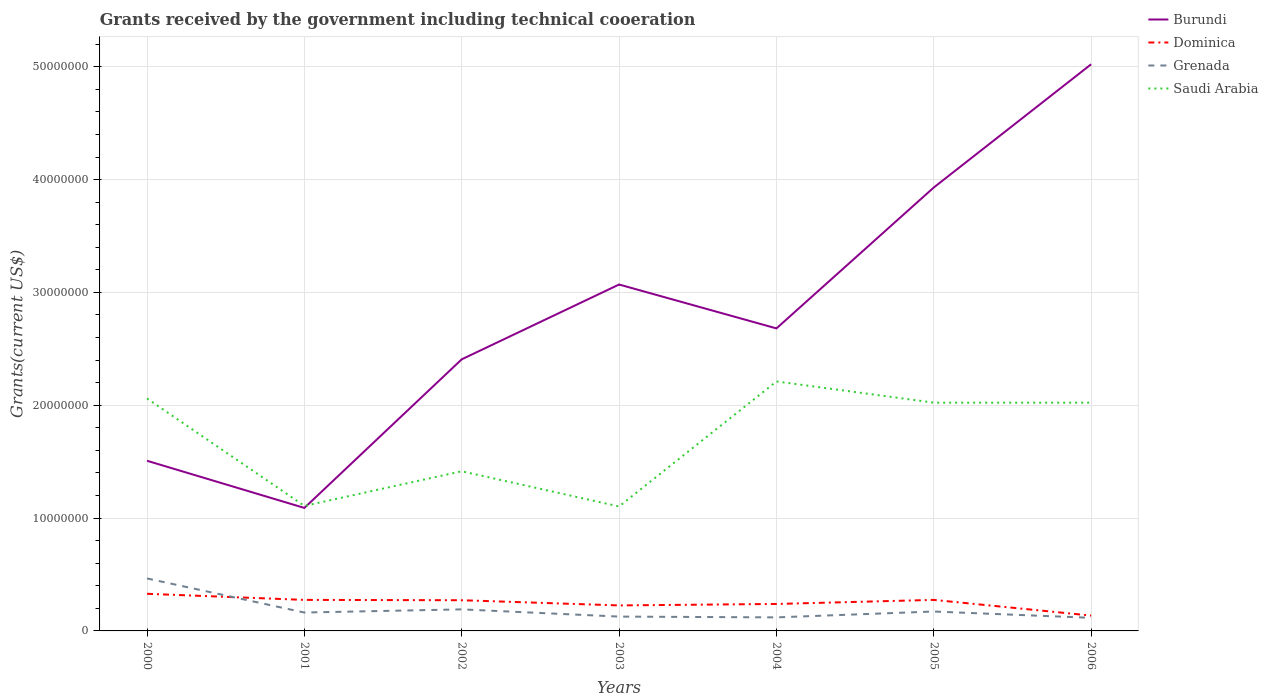Is the number of lines equal to the number of legend labels?
Make the answer very short. Yes. Across all years, what is the maximum total grants received by the government in Saudi Arabia?
Offer a very short reply. 1.10e+07. In which year was the total grants received by the government in Grenada maximum?
Offer a very short reply. 2006. What is the total total grants received by the government in Dominica in the graph?
Provide a succinct answer. 1.03e+06. What is the difference between the highest and the second highest total grants received by the government in Saudi Arabia?
Give a very brief answer. 1.11e+07. What is the difference between the highest and the lowest total grants received by the government in Dominica?
Your response must be concise. 4. Is the total grants received by the government in Saudi Arabia strictly greater than the total grants received by the government in Grenada over the years?
Provide a short and direct response. No. How many lines are there?
Make the answer very short. 4. What is the difference between two consecutive major ticks on the Y-axis?
Provide a succinct answer. 1.00e+07. Where does the legend appear in the graph?
Provide a succinct answer. Top right. How many legend labels are there?
Ensure brevity in your answer.  4. What is the title of the graph?
Keep it short and to the point. Grants received by the government including technical cooeration. Does "Burkina Faso" appear as one of the legend labels in the graph?
Make the answer very short. No. What is the label or title of the X-axis?
Ensure brevity in your answer.  Years. What is the label or title of the Y-axis?
Your answer should be very brief. Grants(current US$). What is the Grants(current US$) of Burundi in 2000?
Ensure brevity in your answer.  1.51e+07. What is the Grants(current US$) of Dominica in 2000?
Make the answer very short. 3.29e+06. What is the Grants(current US$) in Grenada in 2000?
Your response must be concise. 4.65e+06. What is the Grants(current US$) of Saudi Arabia in 2000?
Ensure brevity in your answer.  2.06e+07. What is the Grants(current US$) in Burundi in 2001?
Offer a very short reply. 1.09e+07. What is the Grants(current US$) of Dominica in 2001?
Ensure brevity in your answer.  2.75e+06. What is the Grants(current US$) of Grenada in 2001?
Your answer should be very brief. 1.63e+06. What is the Grants(current US$) of Saudi Arabia in 2001?
Your answer should be very brief. 1.11e+07. What is the Grants(current US$) of Burundi in 2002?
Offer a very short reply. 2.41e+07. What is the Grants(current US$) in Dominica in 2002?
Keep it short and to the point. 2.72e+06. What is the Grants(current US$) of Grenada in 2002?
Offer a terse response. 1.91e+06. What is the Grants(current US$) of Saudi Arabia in 2002?
Provide a succinct answer. 1.42e+07. What is the Grants(current US$) in Burundi in 2003?
Your answer should be compact. 3.07e+07. What is the Grants(current US$) in Dominica in 2003?
Offer a very short reply. 2.26e+06. What is the Grants(current US$) in Grenada in 2003?
Give a very brief answer. 1.27e+06. What is the Grants(current US$) of Saudi Arabia in 2003?
Keep it short and to the point. 1.10e+07. What is the Grants(current US$) in Burundi in 2004?
Your answer should be compact. 2.68e+07. What is the Grants(current US$) of Dominica in 2004?
Offer a terse response. 2.39e+06. What is the Grants(current US$) of Grenada in 2004?
Your response must be concise. 1.20e+06. What is the Grants(current US$) in Saudi Arabia in 2004?
Give a very brief answer. 2.21e+07. What is the Grants(current US$) of Burundi in 2005?
Keep it short and to the point. 3.93e+07. What is the Grants(current US$) of Dominica in 2005?
Provide a short and direct response. 2.75e+06. What is the Grants(current US$) in Grenada in 2005?
Your answer should be compact. 1.72e+06. What is the Grants(current US$) of Saudi Arabia in 2005?
Your answer should be compact. 2.02e+07. What is the Grants(current US$) of Burundi in 2006?
Provide a short and direct response. 5.02e+07. What is the Grants(current US$) of Dominica in 2006?
Offer a terse response. 1.36e+06. What is the Grants(current US$) in Grenada in 2006?
Offer a very short reply. 1.16e+06. What is the Grants(current US$) of Saudi Arabia in 2006?
Offer a terse response. 2.02e+07. Across all years, what is the maximum Grants(current US$) of Burundi?
Offer a terse response. 5.02e+07. Across all years, what is the maximum Grants(current US$) of Dominica?
Your answer should be compact. 3.29e+06. Across all years, what is the maximum Grants(current US$) of Grenada?
Keep it short and to the point. 4.65e+06. Across all years, what is the maximum Grants(current US$) of Saudi Arabia?
Provide a succinct answer. 2.21e+07. Across all years, what is the minimum Grants(current US$) of Burundi?
Make the answer very short. 1.09e+07. Across all years, what is the minimum Grants(current US$) of Dominica?
Offer a terse response. 1.36e+06. Across all years, what is the minimum Grants(current US$) of Grenada?
Offer a very short reply. 1.16e+06. Across all years, what is the minimum Grants(current US$) of Saudi Arabia?
Give a very brief answer. 1.10e+07. What is the total Grants(current US$) of Burundi in the graph?
Your response must be concise. 1.97e+08. What is the total Grants(current US$) of Dominica in the graph?
Offer a very short reply. 1.75e+07. What is the total Grants(current US$) of Grenada in the graph?
Your response must be concise. 1.35e+07. What is the total Grants(current US$) in Saudi Arabia in the graph?
Offer a terse response. 1.19e+08. What is the difference between the Grants(current US$) in Burundi in 2000 and that in 2001?
Provide a succinct answer. 4.18e+06. What is the difference between the Grants(current US$) of Dominica in 2000 and that in 2001?
Your answer should be very brief. 5.40e+05. What is the difference between the Grants(current US$) in Grenada in 2000 and that in 2001?
Offer a terse response. 3.02e+06. What is the difference between the Grants(current US$) of Saudi Arabia in 2000 and that in 2001?
Offer a terse response. 9.52e+06. What is the difference between the Grants(current US$) of Burundi in 2000 and that in 2002?
Keep it short and to the point. -8.99e+06. What is the difference between the Grants(current US$) of Dominica in 2000 and that in 2002?
Offer a terse response. 5.70e+05. What is the difference between the Grants(current US$) of Grenada in 2000 and that in 2002?
Your response must be concise. 2.74e+06. What is the difference between the Grants(current US$) in Saudi Arabia in 2000 and that in 2002?
Keep it short and to the point. 6.45e+06. What is the difference between the Grants(current US$) in Burundi in 2000 and that in 2003?
Ensure brevity in your answer.  -1.56e+07. What is the difference between the Grants(current US$) in Dominica in 2000 and that in 2003?
Offer a very short reply. 1.03e+06. What is the difference between the Grants(current US$) of Grenada in 2000 and that in 2003?
Your answer should be compact. 3.38e+06. What is the difference between the Grants(current US$) in Saudi Arabia in 2000 and that in 2003?
Your answer should be very brief. 9.57e+06. What is the difference between the Grants(current US$) of Burundi in 2000 and that in 2004?
Keep it short and to the point. -1.17e+07. What is the difference between the Grants(current US$) of Grenada in 2000 and that in 2004?
Make the answer very short. 3.45e+06. What is the difference between the Grants(current US$) of Saudi Arabia in 2000 and that in 2004?
Give a very brief answer. -1.51e+06. What is the difference between the Grants(current US$) in Burundi in 2000 and that in 2005?
Provide a succinct answer. -2.42e+07. What is the difference between the Grants(current US$) of Dominica in 2000 and that in 2005?
Provide a succinct answer. 5.40e+05. What is the difference between the Grants(current US$) in Grenada in 2000 and that in 2005?
Offer a terse response. 2.93e+06. What is the difference between the Grants(current US$) in Saudi Arabia in 2000 and that in 2005?
Your answer should be compact. 3.70e+05. What is the difference between the Grants(current US$) of Burundi in 2000 and that in 2006?
Your answer should be compact. -3.51e+07. What is the difference between the Grants(current US$) of Dominica in 2000 and that in 2006?
Offer a very short reply. 1.93e+06. What is the difference between the Grants(current US$) in Grenada in 2000 and that in 2006?
Offer a very short reply. 3.49e+06. What is the difference between the Grants(current US$) of Burundi in 2001 and that in 2002?
Your answer should be compact. -1.32e+07. What is the difference between the Grants(current US$) of Dominica in 2001 and that in 2002?
Provide a succinct answer. 3.00e+04. What is the difference between the Grants(current US$) in Grenada in 2001 and that in 2002?
Your answer should be very brief. -2.80e+05. What is the difference between the Grants(current US$) of Saudi Arabia in 2001 and that in 2002?
Offer a terse response. -3.07e+06. What is the difference between the Grants(current US$) of Burundi in 2001 and that in 2003?
Your response must be concise. -1.98e+07. What is the difference between the Grants(current US$) in Dominica in 2001 and that in 2003?
Ensure brevity in your answer.  4.90e+05. What is the difference between the Grants(current US$) in Grenada in 2001 and that in 2003?
Provide a succinct answer. 3.60e+05. What is the difference between the Grants(current US$) in Saudi Arabia in 2001 and that in 2003?
Keep it short and to the point. 5.00e+04. What is the difference between the Grants(current US$) of Burundi in 2001 and that in 2004?
Make the answer very short. -1.59e+07. What is the difference between the Grants(current US$) in Saudi Arabia in 2001 and that in 2004?
Offer a terse response. -1.10e+07. What is the difference between the Grants(current US$) of Burundi in 2001 and that in 2005?
Make the answer very short. -2.84e+07. What is the difference between the Grants(current US$) of Grenada in 2001 and that in 2005?
Your answer should be compact. -9.00e+04. What is the difference between the Grants(current US$) in Saudi Arabia in 2001 and that in 2005?
Your response must be concise. -9.15e+06. What is the difference between the Grants(current US$) of Burundi in 2001 and that in 2006?
Make the answer very short. -3.93e+07. What is the difference between the Grants(current US$) in Dominica in 2001 and that in 2006?
Your response must be concise. 1.39e+06. What is the difference between the Grants(current US$) in Grenada in 2001 and that in 2006?
Your answer should be compact. 4.70e+05. What is the difference between the Grants(current US$) of Saudi Arabia in 2001 and that in 2006?
Offer a terse response. -9.15e+06. What is the difference between the Grants(current US$) in Burundi in 2002 and that in 2003?
Your response must be concise. -6.63e+06. What is the difference between the Grants(current US$) of Grenada in 2002 and that in 2003?
Keep it short and to the point. 6.40e+05. What is the difference between the Grants(current US$) in Saudi Arabia in 2002 and that in 2003?
Ensure brevity in your answer.  3.12e+06. What is the difference between the Grants(current US$) in Burundi in 2002 and that in 2004?
Your response must be concise. -2.74e+06. What is the difference between the Grants(current US$) of Dominica in 2002 and that in 2004?
Your response must be concise. 3.30e+05. What is the difference between the Grants(current US$) in Grenada in 2002 and that in 2004?
Make the answer very short. 7.10e+05. What is the difference between the Grants(current US$) of Saudi Arabia in 2002 and that in 2004?
Keep it short and to the point. -7.96e+06. What is the difference between the Grants(current US$) of Burundi in 2002 and that in 2005?
Provide a short and direct response. -1.52e+07. What is the difference between the Grants(current US$) of Grenada in 2002 and that in 2005?
Keep it short and to the point. 1.90e+05. What is the difference between the Grants(current US$) in Saudi Arabia in 2002 and that in 2005?
Your response must be concise. -6.08e+06. What is the difference between the Grants(current US$) in Burundi in 2002 and that in 2006?
Offer a very short reply. -2.62e+07. What is the difference between the Grants(current US$) of Dominica in 2002 and that in 2006?
Your answer should be compact. 1.36e+06. What is the difference between the Grants(current US$) in Grenada in 2002 and that in 2006?
Offer a terse response. 7.50e+05. What is the difference between the Grants(current US$) in Saudi Arabia in 2002 and that in 2006?
Give a very brief answer. -6.08e+06. What is the difference between the Grants(current US$) in Burundi in 2003 and that in 2004?
Provide a short and direct response. 3.89e+06. What is the difference between the Grants(current US$) of Grenada in 2003 and that in 2004?
Your response must be concise. 7.00e+04. What is the difference between the Grants(current US$) in Saudi Arabia in 2003 and that in 2004?
Offer a very short reply. -1.11e+07. What is the difference between the Grants(current US$) in Burundi in 2003 and that in 2005?
Make the answer very short. -8.60e+06. What is the difference between the Grants(current US$) of Dominica in 2003 and that in 2005?
Your answer should be compact. -4.90e+05. What is the difference between the Grants(current US$) of Grenada in 2003 and that in 2005?
Give a very brief answer. -4.50e+05. What is the difference between the Grants(current US$) of Saudi Arabia in 2003 and that in 2005?
Keep it short and to the point. -9.20e+06. What is the difference between the Grants(current US$) in Burundi in 2003 and that in 2006?
Offer a very short reply. -1.95e+07. What is the difference between the Grants(current US$) of Grenada in 2003 and that in 2006?
Ensure brevity in your answer.  1.10e+05. What is the difference between the Grants(current US$) in Saudi Arabia in 2003 and that in 2006?
Offer a terse response. -9.20e+06. What is the difference between the Grants(current US$) of Burundi in 2004 and that in 2005?
Your answer should be compact. -1.25e+07. What is the difference between the Grants(current US$) in Dominica in 2004 and that in 2005?
Offer a terse response. -3.60e+05. What is the difference between the Grants(current US$) in Grenada in 2004 and that in 2005?
Give a very brief answer. -5.20e+05. What is the difference between the Grants(current US$) in Saudi Arabia in 2004 and that in 2005?
Provide a succinct answer. 1.88e+06. What is the difference between the Grants(current US$) in Burundi in 2004 and that in 2006?
Your answer should be compact. -2.34e+07. What is the difference between the Grants(current US$) of Dominica in 2004 and that in 2006?
Give a very brief answer. 1.03e+06. What is the difference between the Grants(current US$) in Saudi Arabia in 2004 and that in 2006?
Your answer should be compact. 1.88e+06. What is the difference between the Grants(current US$) in Burundi in 2005 and that in 2006?
Provide a succinct answer. -1.09e+07. What is the difference between the Grants(current US$) in Dominica in 2005 and that in 2006?
Offer a very short reply. 1.39e+06. What is the difference between the Grants(current US$) in Grenada in 2005 and that in 2006?
Offer a terse response. 5.60e+05. What is the difference between the Grants(current US$) of Burundi in 2000 and the Grants(current US$) of Dominica in 2001?
Provide a succinct answer. 1.23e+07. What is the difference between the Grants(current US$) in Burundi in 2000 and the Grants(current US$) in Grenada in 2001?
Give a very brief answer. 1.34e+07. What is the difference between the Grants(current US$) of Dominica in 2000 and the Grants(current US$) of Grenada in 2001?
Make the answer very short. 1.66e+06. What is the difference between the Grants(current US$) in Dominica in 2000 and the Grants(current US$) in Saudi Arabia in 2001?
Your answer should be very brief. -7.79e+06. What is the difference between the Grants(current US$) in Grenada in 2000 and the Grants(current US$) in Saudi Arabia in 2001?
Your answer should be very brief. -6.43e+06. What is the difference between the Grants(current US$) of Burundi in 2000 and the Grants(current US$) of Dominica in 2002?
Your answer should be very brief. 1.24e+07. What is the difference between the Grants(current US$) in Burundi in 2000 and the Grants(current US$) in Grenada in 2002?
Ensure brevity in your answer.  1.32e+07. What is the difference between the Grants(current US$) in Burundi in 2000 and the Grants(current US$) in Saudi Arabia in 2002?
Offer a very short reply. 9.30e+05. What is the difference between the Grants(current US$) in Dominica in 2000 and the Grants(current US$) in Grenada in 2002?
Provide a succinct answer. 1.38e+06. What is the difference between the Grants(current US$) in Dominica in 2000 and the Grants(current US$) in Saudi Arabia in 2002?
Give a very brief answer. -1.09e+07. What is the difference between the Grants(current US$) in Grenada in 2000 and the Grants(current US$) in Saudi Arabia in 2002?
Make the answer very short. -9.50e+06. What is the difference between the Grants(current US$) of Burundi in 2000 and the Grants(current US$) of Dominica in 2003?
Provide a short and direct response. 1.28e+07. What is the difference between the Grants(current US$) in Burundi in 2000 and the Grants(current US$) in Grenada in 2003?
Your answer should be compact. 1.38e+07. What is the difference between the Grants(current US$) in Burundi in 2000 and the Grants(current US$) in Saudi Arabia in 2003?
Keep it short and to the point. 4.05e+06. What is the difference between the Grants(current US$) of Dominica in 2000 and the Grants(current US$) of Grenada in 2003?
Give a very brief answer. 2.02e+06. What is the difference between the Grants(current US$) in Dominica in 2000 and the Grants(current US$) in Saudi Arabia in 2003?
Provide a succinct answer. -7.74e+06. What is the difference between the Grants(current US$) in Grenada in 2000 and the Grants(current US$) in Saudi Arabia in 2003?
Ensure brevity in your answer.  -6.38e+06. What is the difference between the Grants(current US$) of Burundi in 2000 and the Grants(current US$) of Dominica in 2004?
Your answer should be compact. 1.27e+07. What is the difference between the Grants(current US$) in Burundi in 2000 and the Grants(current US$) in Grenada in 2004?
Ensure brevity in your answer.  1.39e+07. What is the difference between the Grants(current US$) in Burundi in 2000 and the Grants(current US$) in Saudi Arabia in 2004?
Make the answer very short. -7.03e+06. What is the difference between the Grants(current US$) of Dominica in 2000 and the Grants(current US$) of Grenada in 2004?
Provide a succinct answer. 2.09e+06. What is the difference between the Grants(current US$) of Dominica in 2000 and the Grants(current US$) of Saudi Arabia in 2004?
Keep it short and to the point. -1.88e+07. What is the difference between the Grants(current US$) in Grenada in 2000 and the Grants(current US$) in Saudi Arabia in 2004?
Make the answer very short. -1.75e+07. What is the difference between the Grants(current US$) in Burundi in 2000 and the Grants(current US$) in Dominica in 2005?
Provide a succinct answer. 1.23e+07. What is the difference between the Grants(current US$) in Burundi in 2000 and the Grants(current US$) in Grenada in 2005?
Provide a short and direct response. 1.34e+07. What is the difference between the Grants(current US$) in Burundi in 2000 and the Grants(current US$) in Saudi Arabia in 2005?
Make the answer very short. -5.15e+06. What is the difference between the Grants(current US$) in Dominica in 2000 and the Grants(current US$) in Grenada in 2005?
Provide a short and direct response. 1.57e+06. What is the difference between the Grants(current US$) of Dominica in 2000 and the Grants(current US$) of Saudi Arabia in 2005?
Ensure brevity in your answer.  -1.69e+07. What is the difference between the Grants(current US$) of Grenada in 2000 and the Grants(current US$) of Saudi Arabia in 2005?
Offer a terse response. -1.56e+07. What is the difference between the Grants(current US$) in Burundi in 2000 and the Grants(current US$) in Dominica in 2006?
Your answer should be very brief. 1.37e+07. What is the difference between the Grants(current US$) of Burundi in 2000 and the Grants(current US$) of Grenada in 2006?
Provide a succinct answer. 1.39e+07. What is the difference between the Grants(current US$) of Burundi in 2000 and the Grants(current US$) of Saudi Arabia in 2006?
Offer a terse response. -5.15e+06. What is the difference between the Grants(current US$) in Dominica in 2000 and the Grants(current US$) in Grenada in 2006?
Keep it short and to the point. 2.13e+06. What is the difference between the Grants(current US$) in Dominica in 2000 and the Grants(current US$) in Saudi Arabia in 2006?
Offer a terse response. -1.69e+07. What is the difference between the Grants(current US$) of Grenada in 2000 and the Grants(current US$) of Saudi Arabia in 2006?
Ensure brevity in your answer.  -1.56e+07. What is the difference between the Grants(current US$) of Burundi in 2001 and the Grants(current US$) of Dominica in 2002?
Make the answer very short. 8.18e+06. What is the difference between the Grants(current US$) in Burundi in 2001 and the Grants(current US$) in Grenada in 2002?
Keep it short and to the point. 8.99e+06. What is the difference between the Grants(current US$) in Burundi in 2001 and the Grants(current US$) in Saudi Arabia in 2002?
Offer a terse response. -3.25e+06. What is the difference between the Grants(current US$) of Dominica in 2001 and the Grants(current US$) of Grenada in 2002?
Your response must be concise. 8.40e+05. What is the difference between the Grants(current US$) of Dominica in 2001 and the Grants(current US$) of Saudi Arabia in 2002?
Your answer should be compact. -1.14e+07. What is the difference between the Grants(current US$) of Grenada in 2001 and the Grants(current US$) of Saudi Arabia in 2002?
Your answer should be compact. -1.25e+07. What is the difference between the Grants(current US$) of Burundi in 2001 and the Grants(current US$) of Dominica in 2003?
Give a very brief answer. 8.64e+06. What is the difference between the Grants(current US$) of Burundi in 2001 and the Grants(current US$) of Grenada in 2003?
Your answer should be compact. 9.63e+06. What is the difference between the Grants(current US$) in Burundi in 2001 and the Grants(current US$) in Saudi Arabia in 2003?
Provide a short and direct response. -1.30e+05. What is the difference between the Grants(current US$) of Dominica in 2001 and the Grants(current US$) of Grenada in 2003?
Ensure brevity in your answer.  1.48e+06. What is the difference between the Grants(current US$) in Dominica in 2001 and the Grants(current US$) in Saudi Arabia in 2003?
Give a very brief answer. -8.28e+06. What is the difference between the Grants(current US$) of Grenada in 2001 and the Grants(current US$) of Saudi Arabia in 2003?
Make the answer very short. -9.40e+06. What is the difference between the Grants(current US$) of Burundi in 2001 and the Grants(current US$) of Dominica in 2004?
Your answer should be very brief. 8.51e+06. What is the difference between the Grants(current US$) of Burundi in 2001 and the Grants(current US$) of Grenada in 2004?
Ensure brevity in your answer.  9.70e+06. What is the difference between the Grants(current US$) in Burundi in 2001 and the Grants(current US$) in Saudi Arabia in 2004?
Keep it short and to the point. -1.12e+07. What is the difference between the Grants(current US$) in Dominica in 2001 and the Grants(current US$) in Grenada in 2004?
Offer a very short reply. 1.55e+06. What is the difference between the Grants(current US$) in Dominica in 2001 and the Grants(current US$) in Saudi Arabia in 2004?
Provide a short and direct response. -1.94e+07. What is the difference between the Grants(current US$) of Grenada in 2001 and the Grants(current US$) of Saudi Arabia in 2004?
Provide a short and direct response. -2.05e+07. What is the difference between the Grants(current US$) of Burundi in 2001 and the Grants(current US$) of Dominica in 2005?
Your answer should be very brief. 8.15e+06. What is the difference between the Grants(current US$) in Burundi in 2001 and the Grants(current US$) in Grenada in 2005?
Provide a short and direct response. 9.18e+06. What is the difference between the Grants(current US$) in Burundi in 2001 and the Grants(current US$) in Saudi Arabia in 2005?
Make the answer very short. -9.33e+06. What is the difference between the Grants(current US$) in Dominica in 2001 and the Grants(current US$) in Grenada in 2005?
Offer a very short reply. 1.03e+06. What is the difference between the Grants(current US$) of Dominica in 2001 and the Grants(current US$) of Saudi Arabia in 2005?
Your answer should be very brief. -1.75e+07. What is the difference between the Grants(current US$) in Grenada in 2001 and the Grants(current US$) in Saudi Arabia in 2005?
Provide a succinct answer. -1.86e+07. What is the difference between the Grants(current US$) of Burundi in 2001 and the Grants(current US$) of Dominica in 2006?
Offer a very short reply. 9.54e+06. What is the difference between the Grants(current US$) of Burundi in 2001 and the Grants(current US$) of Grenada in 2006?
Give a very brief answer. 9.74e+06. What is the difference between the Grants(current US$) in Burundi in 2001 and the Grants(current US$) in Saudi Arabia in 2006?
Provide a succinct answer. -9.33e+06. What is the difference between the Grants(current US$) of Dominica in 2001 and the Grants(current US$) of Grenada in 2006?
Your response must be concise. 1.59e+06. What is the difference between the Grants(current US$) of Dominica in 2001 and the Grants(current US$) of Saudi Arabia in 2006?
Your answer should be compact. -1.75e+07. What is the difference between the Grants(current US$) in Grenada in 2001 and the Grants(current US$) in Saudi Arabia in 2006?
Provide a short and direct response. -1.86e+07. What is the difference between the Grants(current US$) of Burundi in 2002 and the Grants(current US$) of Dominica in 2003?
Give a very brief answer. 2.18e+07. What is the difference between the Grants(current US$) in Burundi in 2002 and the Grants(current US$) in Grenada in 2003?
Your response must be concise. 2.28e+07. What is the difference between the Grants(current US$) of Burundi in 2002 and the Grants(current US$) of Saudi Arabia in 2003?
Provide a succinct answer. 1.30e+07. What is the difference between the Grants(current US$) in Dominica in 2002 and the Grants(current US$) in Grenada in 2003?
Give a very brief answer. 1.45e+06. What is the difference between the Grants(current US$) in Dominica in 2002 and the Grants(current US$) in Saudi Arabia in 2003?
Give a very brief answer. -8.31e+06. What is the difference between the Grants(current US$) of Grenada in 2002 and the Grants(current US$) of Saudi Arabia in 2003?
Offer a terse response. -9.12e+06. What is the difference between the Grants(current US$) in Burundi in 2002 and the Grants(current US$) in Dominica in 2004?
Provide a short and direct response. 2.17e+07. What is the difference between the Grants(current US$) in Burundi in 2002 and the Grants(current US$) in Grenada in 2004?
Make the answer very short. 2.29e+07. What is the difference between the Grants(current US$) in Burundi in 2002 and the Grants(current US$) in Saudi Arabia in 2004?
Provide a short and direct response. 1.96e+06. What is the difference between the Grants(current US$) of Dominica in 2002 and the Grants(current US$) of Grenada in 2004?
Ensure brevity in your answer.  1.52e+06. What is the difference between the Grants(current US$) in Dominica in 2002 and the Grants(current US$) in Saudi Arabia in 2004?
Your answer should be very brief. -1.94e+07. What is the difference between the Grants(current US$) in Grenada in 2002 and the Grants(current US$) in Saudi Arabia in 2004?
Your answer should be very brief. -2.02e+07. What is the difference between the Grants(current US$) of Burundi in 2002 and the Grants(current US$) of Dominica in 2005?
Offer a terse response. 2.13e+07. What is the difference between the Grants(current US$) in Burundi in 2002 and the Grants(current US$) in Grenada in 2005?
Provide a succinct answer. 2.24e+07. What is the difference between the Grants(current US$) in Burundi in 2002 and the Grants(current US$) in Saudi Arabia in 2005?
Offer a very short reply. 3.84e+06. What is the difference between the Grants(current US$) in Dominica in 2002 and the Grants(current US$) in Grenada in 2005?
Ensure brevity in your answer.  1.00e+06. What is the difference between the Grants(current US$) in Dominica in 2002 and the Grants(current US$) in Saudi Arabia in 2005?
Your answer should be very brief. -1.75e+07. What is the difference between the Grants(current US$) in Grenada in 2002 and the Grants(current US$) in Saudi Arabia in 2005?
Offer a terse response. -1.83e+07. What is the difference between the Grants(current US$) of Burundi in 2002 and the Grants(current US$) of Dominica in 2006?
Give a very brief answer. 2.27e+07. What is the difference between the Grants(current US$) of Burundi in 2002 and the Grants(current US$) of Grenada in 2006?
Offer a terse response. 2.29e+07. What is the difference between the Grants(current US$) in Burundi in 2002 and the Grants(current US$) in Saudi Arabia in 2006?
Offer a very short reply. 3.84e+06. What is the difference between the Grants(current US$) of Dominica in 2002 and the Grants(current US$) of Grenada in 2006?
Offer a very short reply. 1.56e+06. What is the difference between the Grants(current US$) in Dominica in 2002 and the Grants(current US$) in Saudi Arabia in 2006?
Your answer should be compact. -1.75e+07. What is the difference between the Grants(current US$) of Grenada in 2002 and the Grants(current US$) of Saudi Arabia in 2006?
Provide a succinct answer. -1.83e+07. What is the difference between the Grants(current US$) in Burundi in 2003 and the Grants(current US$) in Dominica in 2004?
Provide a succinct answer. 2.83e+07. What is the difference between the Grants(current US$) in Burundi in 2003 and the Grants(current US$) in Grenada in 2004?
Your answer should be compact. 2.95e+07. What is the difference between the Grants(current US$) in Burundi in 2003 and the Grants(current US$) in Saudi Arabia in 2004?
Your response must be concise. 8.59e+06. What is the difference between the Grants(current US$) in Dominica in 2003 and the Grants(current US$) in Grenada in 2004?
Provide a short and direct response. 1.06e+06. What is the difference between the Grants(current US$) in Dominica in 2003 and the Grants(current US$) in Saudi Arabia in 2004?
Your response must be concise. -1.98e+07. What is the difference between the Grants(current US$) in Grenada in 2003 and the Grants(current US$) in Saudi Arabia in 2004?
Your answer should be compact. -2.08e+07. What is the difference between the Grants(current US$) of Burundi in 2003 and the Grants(current US$) of Dominica in 2005?
Ensure brevity in your answer.  2.80e+07. What is the difference between the Grants(current US$) in Burundi in 2003 and the Grants(current US$) in Grenada in 2005?
Make the answer very short. 2.90e+07. What is the difference between the Grants(current US$) of Burundi in 2003 and the Grants(current US$) of Saudi Arabia in 2005?
Make the answer very short. 1.05e+07. What is the difference between the Grants(current US$) in Dominica in 2003 and the Grants(current US$) in Grenada in 2005?
Keep it short and to the point. 5.40e+05. What is the difference between the Grants(current US$) of Dominica in 2003 and the Grants(current US$) of Saudi Arabia in 2005?
Ensure brevity in your answer.  -1.80e+07. What is the difference between the Grants(current US$) of Grenada in 2003 and the Grants(current US$) of Saudi Arabia in 2005?
Give a very brief answer. -1.90e+07. What is the difference between the Grants(current US$) of Burundi in 2003 and the Grants(current US$) of Dominica in 2006?
Provide a succinct answer. 2.93e+07. What is the difference between the Grants(current US$) in Burundi in 2003 and the Grants(current US$) in Grenada in 2006?
Offer a very short reply. 2.95e+07. What is the difference between the Grants(current US$) in Burundi in 2003 and the Grants(current US$) in Saudi Arabia in 2006?
Provide a short and direct response. 1.05e+07. What is the difference between the Grants(current US$) in Dominica in 2003 and the Grants(current US$) in Grenada in 2006?
Provide a short and direct response. 1.10e+06. What is the difference between the Grants(current US$) of Dominica in 2003 and the Grants(current US$) of Saudi Arabia in 2006?
Keep it short and to the point. -1.80e+07. What is the difference between the Grants(current US$) in Grenada in 2003 and the Grants(current US$) in Saudi Arabia in 2006?
Give a very brief answer. -1.90e+07. What is the difference between the Grants(current US$) of Burundi in 2004 and the Grants(current US$) of Dominica in 2005?
Make the answer very short. 2.41e+07. What is the difference between the Grants(current US$) of Burundi in 2004 and the Grants(current US$) of Grenada in 2005?
Provide a succinct answer. 2.51e+07. What is the difference between the Grants(current US$) in Burundi in 2004 and the Grants(current US$) in Saudi Arabia in 2005?
Ensure brevity in your answer.  6.58e+06. What is the difference between the Grants(current US$) of Dominica in 2004 and the Grants(current US$) of Grenada in 2005?
Offer a terse response. 6.70e+05. What is the difference between the Grants(current US$) of Dominica in 2004 and the Grants(current US$) of Saudi Arabia in 2005?
Your answer should be compact. -1.78e+07. What is the difference between the Grants(current US$) in Grenada in 2004 and the Grants(current US$) in Saudi Arabia in 2005?
Your answer should be very brief. -1.90e+07. What is the difference between the Grants(current US$) of Burundi in 2004 and the Grants(current US$) of Dominica in 2006?
Offer a very short reply. 2.54e+07. What is the difference between the Grants(current US$) of Burundi in 2004 and the Grants(current US$) of Grenada in 2006?
Ensure brevity in your answer.  2.56e+07. What is the difference between the Grants(current US$) in Burundi in 2004 and the Grants(current US$) in Saudi Arabia in 2006?
Provide a short and direct response. 6.58e+06. What is the difference between the Grants(current US$) of Dominica in 2004 and the Grants(current US$) of Grenada in 2006?
Your response must be concise. 1.23e+06. What is the difference between the Grants(current US$) of Dominica in 2004 and the Grants(current US$) of Saudi Arabia in 2006?
Keep it short and to the point. -1.78e+07. What is the difference between the Grants(current US$) of Grenada in 2004 and the Grants(current US$) of Saudi Arabia in 2006?
Make the answer very short. -1.90e+07. What is the difference between the Grants(current US$) of Burundi in 2005 and the Grants(current US$) of Dominica in 2006?
Your response must be concise. 3.79e+07. What is the difference between the Grants(current US$) in Burundi in 2005 and the Grants(current US$) in Grenada in 2006?
Ensure brevity in your answer.  3.81e+07. What is the difference between the Grants(current US$) in Burundi in 2005 and the Grants(current US$) in Saudi Arabia in 2006?
Offer a terse response. 1.91e+07. What is the difference between the Grants(current US$) in Dominica in 2005 and the Grants(current US$) in Grenada in 2006?
Your response must be concise. 1.59e+06. What is the difference between the Grants(current US$) of Dominica in 2005 and the Grants(current US$) of Saudi Arabia in 2006?
Offer a terse response. -1.75e+07. What is the difference between the Grants(current US$) in Grenada in 2005 and the Grants(current US$) in Saudi Arabia in 2006?
Provide a short and direct response. -1.85e+07. What is the average Grants(current US$) in Burundi per year?
Your response must be concise. 2.82e+07. What is the average Grants(current US$) in Dominica per year?
Your answer should be very brief. 2.50e+06. What is the average Grants(current US$) of Grenada per year?
Provide a succinct answer. 1.93e+06. What is the average Grants(current US$) of Saudi Arabia per year?
Offer a terse response. 1.71e+07. In the year 2000, what is the difference between the Grants(current US$) in Burundi and Grants(current US$) in Dominica?
Provide a short and direct response. 1.18e+07. In the year 2000, what is the difference between the Grants(current US$) of Burundi and Grants(current US$) of Grenada?
Keep it short and to the point. 1.04e+07. In the year 2000, what is the difference between the Grants(current US$) of Burundi and Grants(current US$) of Saudi Arabia?
Your answer should be very brief. -5.52e+06. In the year 2000, what is the difference between the Grants(current US$) in Dominica and Grants(current US$) in Grenada?
Your answer should be compact. -1.36e+06. In the year 2000, what is the difference between the Grants(current US$) in Dominica and Grants(current US$) in Saudi Arabia?
Ensure brevity in your answer.  -1.73e+07. In the year 2000, what is the difference between the Grants(current US$) in Grenada and Grants(current US$) in Saudi Arabia?
Offer a terse response. -1.60e+07. In the year 2001, what is the difference between the Grants(current US$) of Burundi and Grants(current US$) of Dominica?
Give a very brief answer. 8.15e+06. In the year 2001, what is the difference between the Grants(current US$) in Burundi and Grants(current US$) in Grenada?
Make the answer very short. 9.27e+06. In the year 2001, what is the difference between the Grants(current US$) of Dominica and Grants(current US$) of Grenada?
Ensure brevity in your answer.  1.12e+06. In the year 2001, what is the difference between the Grants(current US$) in Dominica and Grants(current US$) in Saudi Arabia?
Your answer should be compact. -8.33e+06. In the year 2001, what is the difference between the Grants(current US$) in Grenada and Grants(current US$) in Saudi Arabia?
Your answer should be very brief. -9.45e+06. In the year 2002, what is the difference between the Grants(current US$) in Burundi and Grants(current US$) in Dominica?
Your answer should be very brief. 2.14e+07. In the year 2002, what is the difference between the Grants(current US$) of Burundi and Grants(current US$) of Grenada?
Offer a very short reply. 2.22e+07. In the year 2002, what is the difference between the Grants(current US$) of Burundi and Grants(current US$) of Saudi Arabia?
Ensure brevity in your answer.  9.92e+06. In the year 2002, what is the difference between the Grants(current US$) of Dominica and Grants(current US$) of Grenada?
Provide a succinct answer. 8.10e+05. In the year 2002, what is the difference between the Grants(current US$) of Dominica and Grants(current US$) of Saudi Arabia?
Offer a very short reply. -1.14e+07. In the year 2002, what is the difference between the Grants(current US$) in Grenada and Grants(current US$) in Saudi Arabia?
Your answer should be very brief. -1.22e+07. In the year 2003, what is the difference between the Grants(current US$) of Burundi and Grants(current US$) of Dominica?
Ensure brevity in your answer.  2.84e+07. In the year 2003, what is the difference between the Grants(current US$) in Burundi and Grants(current US$) in Grenada?
Provide a short and direct response. 2.94e+07. In the year 2003, what is the difference between the Grants(current US$) of Burundi and Grants(current US$) of Saudi Arabia?
Your answer should be compact. 1.97e+07. In the year 2003, what is the difference between the Grants(current US$) of Dominica and Grants(current US$) of Grenada?
Give a very brief answer. 9.90e+05. In the year 2003, what is the difference between the Grants(current US$) in Dominica and Grants(current US$) in Saudi Arabia?
Offer a terse response. -8.77e+06. In the year 2003, what is the difference between the Grants(current US$) in Grenada and Grants(current US$) in Saudi Arabia?
Your answer should be compact. -9.76e+06. In the year 2004, what is the difference between the Grants(current US$) in Burundi and Grants(current US$) in Dominica?
Provide a succinct answer. 2.44e+07. In the year 2004, what is the difference between the Grants(current US$) in Burundi and Grants(current US$) in Grenada?
Make the answer very short. 2.56e+07. In the year 2004, what is the difference between the Grants(current US$) in Burundi and Grants(current US$) in Saudi Arabia?
Your answer should be compact. 4.70e+06. In the year 2004, what is the difference between the Grants(current US$) in Dominica and Grants(current US$) in Grenada?
Offer a very short reply. 1.19e+06. In the year 2004, what is the difference between the Grants(current US$) of Dominica and Grants(current US$) of Saudi Arabia?
Ensure brevity in your answer.  -1.97e+07. In the year 2004, what is the difference between the Grants(current US$) in Grenada and Grants(current US$) in Saudi Arabia?
Your answer should be very brief. -2.09e+07. In the year 2005, what is the difference between the Grants(current US$) of Burundi and Grants(current US$) of Dominica?
Offer a terse response. 3.66e+07. In the year 2005, what is the difference between the Grants(current US$) of Burundi and Grants(current US$) of Grenada?
Make the answer very short. 3.76e+07. In the year 2005, what is the difference between the Grants(current US$) in Burundi and Grants(current US$) in Saudi Arabia?
Provide a succinct answer. 1.91e+07. In the year 2005, what is the difference between the Grants(current US$) of Dominica and Grants(current US$) of Grenada?
Provide a succinct answer. 1.03e+06. In the year 2005, what is the difference between the Grants(current US$) of Dominica and Grants(current US$) of Saudi Arabia?
Give a very brief answer. -1.75e+07. In the year 2005, what is the difference between the Grants(current US$) of Grenada and Grants(current US$) of Saudi Arabia?
Keep it short and to the point. -1.85e+07. In the year 2006, what is the difference between the Grants(current US$) in Burundi and Grants(current US$) in Dominica?
Give a very brief answer. 4.89e+07. In the year 2006, what is the difference between the Grants(current US$) in Burundi and Grants(current US$) in Grenada?
Offer a very short reply. 4.91e+07. In the year 2006, what is the difference between the Grants(current US$) in Burundi and Grants(current US$) in Saudi Arabia?
Your answer should be very brief. 3.00e+07. In the year 2006, what is the difference between the Grants(current US$) of Dominica and Grants(current US$) of Grenada?
Provide a succinct answer. 2.00e+05. In the year 2006, what is the difference between the Grants(current US$) in Dominica and Grants(current US$) in Saudi Arabia?
Give a very brief answer. -1.89e+07. In the year 2006, what is the difference between the Grants(current US$) of Grenada and Grants(current US$) of Saudi Arabia?
Make the answer very short. -1.91e+07. What is the ratio of the Grants(current US$) of Burundi in 2000 to that in 2001?
Your answer should be very brief. 1.38. What is the ratio of the Grants(current US$) in Dominica in 2000 to that in 2001?
Provide a succinct answer. 1.2. What is the ratio of the Grants(current US$) in Grenada in 2000 to that in 2001?
Offer a terse response. 2.85. What is the ratio of the Grants(current US$) in Saudi Arabia in 2000 to that in 2001?
Provide a short and direct response. 1.86. What is the ratio of the Grants(current US$) in Burundi in 2000 to that in 2002?
Provide a succinct answer. 0.63. What is the ratio of the Grants(current US$) in Dominica in 2000 to that in 2002?
Make the answer very short. 1.21. What is the ratio of the Grants(current US$) in Grenada in 2000 to that in 2002?
Your answer should be compact. 2.43. What is the ratio of the Grants(current US$) in Saudi Arabia in 2000 to that in 2002?
Your answer should be compact. 1.46. What is the ratio of the Grants(current US$) in Burundi in 2000 to that in 2003?
Provide a succinct answer. 0.49. What is the ratio of the Grants(current US$) of Dominica in 2000 to that in 2003?
Provide a short and direct response. 1.46. What is the ratio of the Grants(current US$) in Grenada in 2000 to that in 2003?
Your answer should be very brief. 3.66. What is the ratio of the Grants(current US$) in Saudi Arabia in 2000 to that in 2003?
Offer a terse response. 1.87. What is the ratio of the Grants(current US$) of Burundi in 2000 to that in 2004?
Your answer should be very brief. 0.56. What is the ratio of the Grants(current US$) of Dominica in 2000 to that in 2004?
Give a very brief answer. 1.38. What is the ratio of the Grants(current US$) in Grenada in 2000 to that in 2004?
Keep it short and to the point. 3.88. What is the ratio of the Grants(current US$) in Saudi Arabia in 2000 to that in 2004?
Ensure brevity in your answer.  0.93. What is the ratio of the Grants(current US$) in Burundi in 2000 to that in 2005?
Provide a succinct answer. 0.38. What is the ratio of the Grants(current US$) in Dominica in 2000 to that in 2005?
Keep it short and to the point. 1.2. What is the ratio of the Grants(current US$) of Grenada in 2000 to that in 2005?
Give a very brief answer. 2.7. What is the ratio of the Grants(current US$) in Saudi Arabia in 2000 to that in 2005?
Provide a short and direct response. 1.02. What is the ratio of the Grants(current US$) in Burundi in 2000 to that in 2006?
Offer a terse response. 0.3. What is the ratio of the Grants(current US$) in Dominica in 2000 to that in 2006?
Keep it short and to the point. 2.42. What is the ratio of the Grants(current US$) in Grenada in 2000 to that in 2006?
Offer a very short reply. 4.01. What is the ratio of the Grants(current US$) in Saudi Arabia in 2000 to that in 2006?
Ensure brevity in your answer.  1.02. What is the ratio of the Grants(current US$) in Burundi in 2001 to that in 2002?
Provide a short and direct response. 0.45. What is the ratio of the Grants(current US$) of Dominica in 2001 to that in 2002?
Offer a terse response. 1.01. What is the ratio of the Grants(current US$) of Grenada in 2001 to that in 2002?
Your response must be concise. 0.85. What is the ratio of the Grants(current US$) in Saudi Arabia in 2001 to that in 2002?
Make the answer very short. 0.78. What is the ratio of the Grants(current US$) of Burundi in 2001 to that in 2003?
Ensure brevity in your answer.  0.35. What is the ratio of the Grants(current US$) of Dominica in 2001 to that in 2003?
Keep it short and to the point. 1.22. What is the ratio of the Grants(current US$) in Grenada in 2001 to that in 2003?
Make the answer very short. 1.28. What is the ratio of the Grants(current US$) of Burundi in 2001 to that in 2004?
Make the answer very short. 0.41. What is the ratio of the Grants(current US$) of Dominica in 2001 to that in 2004?
Give a very brief answer. 1.15. What is the ratio of the Grants(current US$) of Grenada in 2001 to that in 2004?
Ensure brevity in your answer.  1.36. What is the ratio of the Grants(current US$) of Saudi Arabia in 2001 to that in 2004?
Your response must be concise. 0.5. What is the ratio of the Grants(current US$) in Burundi in 2001 to that in 2005?
Your answer should be very brief. 0.28. What is the ratio of the Grants(current US$) in Dominica in 2001 to that in 2005?
Provide a succinct answer. 1. What is the ratio of the Grants(current US$) of Grenada in 2001 to that in 2005?
Provide a succinct answer. 0.95. What is the ratio of the Grants(current US$) in Saudi Arabia in 2001 to that in 2005?
Your response must be concise. 0.55. What is the ratio of the Grants(current US$) in Burundi in 2001 to that in 2006?
Give a very brief answer. 0.22. What is the ratio of the Grants(current US$) of Dominica in 2001 to that in 2006?
Provide a short and direct response. 2.02. What is the ratio of the Grants(current US$) in Grenada in 2001 to that in 2006?
Your answer should be compact. 1.41. What is the ratio of the Grants(current US$) in Saudi Arabia in 2001 to that in 2006?
Offer a terse response. 0.55. What is the ratio of the Grants(current US$) of Burundi in 2002 to that in 2003?
Give a very brief answer. 0.78. What is the ratio of the Grants(current US$) in Dominica in 2002 to that in 2003?
Offer a terse response. 1.2. What is the ratio of the Grants(current US$) in Grenada in 2002 to that in 2003?
Ensure brevity in your answer.  1.5. What is the ratio of the Grants(current US$) in Saudi Arabia in 2002 to that in 2003?
Offer a terse response. 1.28. What is the ratio of the Grants(current US$) in Burundi in 2002 to that in 2004?
Make the answer very short. 0.9. What is the ratio of the Grants(current US$) in Dominica in 2002 to that in 2004?
Your answer should be compact. 1.14. What is the ratio of the Grants(current US$) in Grenada in 2002 to that in 2004?
Make the answer very short. 1.59. What is the ratio of the Grants(current US$) in Saudi Arabia in 2002 to that in 2004?
Keep it short and to the point. 0.64. What is the ratio of the Grants(current US$) of Burundi in 2002 to that in 2005?
Offer a very short reply. 0.61. What is the ratio of the Grants(current US$) in Grenada in 2002 to that in 2005?
Your answer should be very brief. 1.11. What is the ratio of the Grants(current US$) in Saudi Arabia in 2002 to that in 2005?
Your answer should be very brief. 0.7. What is the ratio of the Grants(current US$) of Burundi in 2002 to that in 2006?
Your answer should be very brief. 0.48. What is the ratio of the Grants(current US$) in Grenada in 2002 to that in 2006?
Offer a terse response. 1.65. What is the ratio of the Grants(current US$) in Saudi Arabia in 2002 to that in 2006?
Provide a short and direct response. 0.7. What is the ratio of the Grants(current US$) of Burundi in 2003 to that in 2004?
Make the answer very short. 1.15. What is the ratio of the Grants(current US$) of Dominica in 2003 to that in 2004?
Ensure brevity in your answer.  0.95. What is the ratio of the Grants(current US$) of Grenada in 2003 to that in 2004?
Your response must be concise. 1.06. What is the ratio of the Grants(current US$) of Saudi Arabia in 2003 to that in 2004?
Offer a terse response. 0.5. What is the ratio of the Grants(current US$) in Burundi in 2003 to that in 2005?
Your answer should be very brief. 0.78. What is the ratio of the Grants(current US$) of Dominica in 2003 to that in 2005?
Your answer should be compact. 0.82. What is the ratio of the Grants(current US$) of Grenada in 2003 to that in 2005?
Offer a terse response. 0.74. What is the ratio of the Grants(current US$) of Saudi Arabia in 2003 to that in 2005?
Make the answer very short. 0.55. What is the ratio of the Grants(current US$) of Burundi in 2003 to that in 2006?
Keep it short and to the point. 0.61. What is the ratio of the Grants(current US$) in Dominica in 2003 to that in 2006?
Give a very brief answer. 1.66. What is the ratio of the Grants(current US$) of Grenada in 2003 to that in 2006?
Provide a succinct answer. 1.09. What is the ratio of the Grants(current US$) in Saudi Arabia in 2003 to that in 2006?
Keep it short and to the point. 0.55. What is the ratio of the Grants(current US$) of Burundi in 2004 to that in 2005?
Provide a succinct answer. 0.68. What is the ratio of the Grants(current US$) in Dominica in 2004 to that in 2005?
Offer a terse response. 0.87. What is the ratio of the Grants(current US$) of Grenada in 2004 to that in 2005?
Provide a succinct answer. 0.7. What is the ratio of the Grants(current US$) of Saudi Arabia in 2004 to that in 2005?
Your response must be concise. 1.09. What is the ratio of the Grants(current US$) of Burundi in 2004 to that in 2006?
Keep it short and to the point. 0.53. What is the ratio of the Grants(current US$) of Dominica in 2004 to that in 2006?
Provide a short and direct response. 1.76. What is the ratio of the Grants(current US$) of Grenada in 2004 to that in 2006?
Your answer should be very brief. 1.03. What is the ratio of the Grants(current US$) in Saudi Arabia in 2004 to that in 2006?
Your answer should be very brief. 1.09. What is the ratio of the Grants(current US$) in Burundi in 2005 to that in 2006?
Offer a terse response. 0.78. What is the ratio of the Grants(current US$) in Dominica in 2005 to that in 2006?
Offer a very short reply. 2.02. What is the ratio of the Grants(current US$) in Grenada in 2005 to that in 2006?
Your answer should be very brief. 1.48. What is the ratio of the Grants(current US$) in Saudi Arabia in 2005 to that in 2006?
Ensure brevity in your answer.  1. What is the difference between the highest and the second highest Grants(current US$) of Burundi?
Ensure brevity in your answer.  1.09e+07. What is the difference between the highest and the second highest Grants(current US$) in Dominica?
Keep it short and to the point. 5.40e+05. What is the difference between the highest and the second highest Grants(current US$) of Grenada?
Keep it short and to the point. 2.74e+06. What is the difference between the highest and the second highest Grants(current US$) of Saudi Arabia?
Provide a short and direct response. 1.51e+06. What is the difference between the highest and the lowest Grants(current US$) of Burundi?
Offer a very short reply. 3.93e+07. What is the difference between the highest and the lowest Grants(current US$) of Dominica?
Provide a short and direct response. 1.93e+06. What is the difference between the highest and the lowest Grants(current US$) of Grenada?
Your answer should be very brief. 3.49e+06. What is the difference between the highest and the lowest Grants(current US$) in Saudi Arabia?
Offer a terse response. 1.11e+07. 